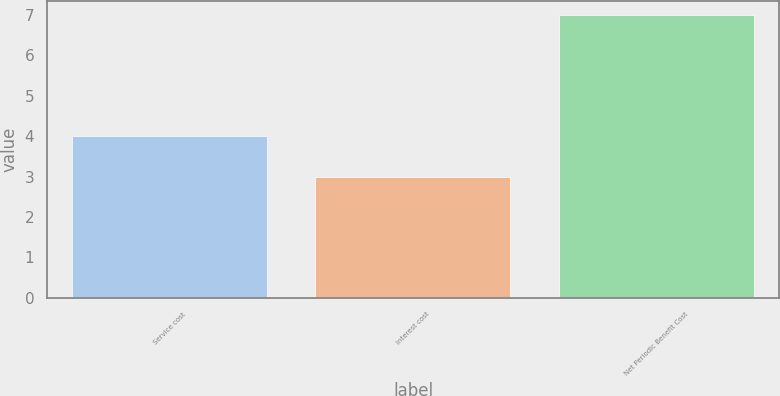Convert chart to OTSL. <chart><loc_0><loc_0><loc_500><loc_500><bar_chart><fcel>Service cost<fcel>Interest cost<fcel>Net Periodic Benefit Cost<nl><fcel>4<fcel>3<fcel>7<nl></chart> 